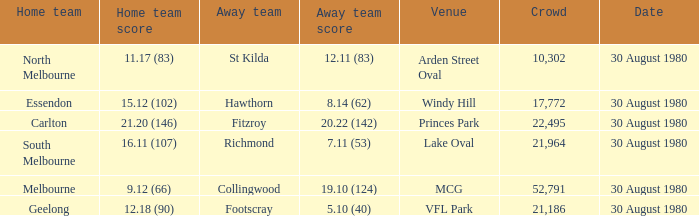What was the crowd when the away team is footscray? 21186.0. 